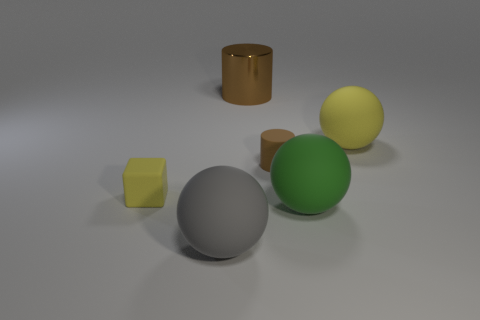Are there any other things that are made of the same material as the large brown cylinder?
Offer a terse response. No. There is a brown thing that is to the right of the brown cylinder that is behind the big yellow thing; what is its shape?
Offer a very short reply. Cylinder. Are there any tiny blocks in front of the small matte cube?
Your answer should be very brief. No. There is a cylinder that is the same size as the gray ball; what color is it?
Provide a succinct answer. Brown. What number of large objects are made of the same material as the yellow block?
Your response must be concise. 3. How many other objects are there of the same size as the yellow sphere?
Your answer should be compact. 3. Is there a gray matte sphere of the same size as the gray matte object?
Ensure brevity in your answer.  No. Is the color of the big object that is behind the big yellow matte sphere the same as the matte cylinder?
Your answer should be very brief. Yes. How many objects are either metal things or small blue rubber objects?
Provide a short and direct response. 1. Do the cylinder on the right side of the metal cylinder and the large brown cylinder have the same size?
Keep it short and to the point. No. 